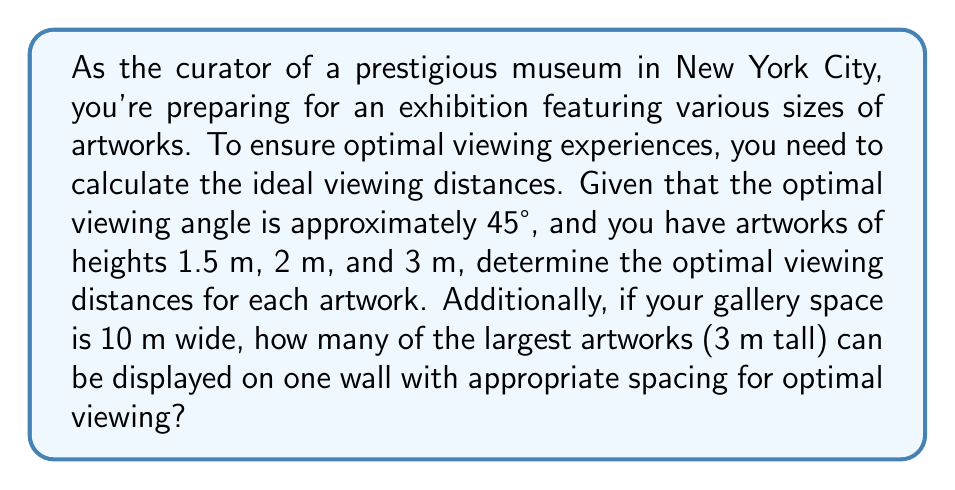Provide a solution to this math problem. To solve this problem, we'll use principles of functional analysis and geometry:

1. Optimal viewing distance calculation:
   The optimal viewing angle of 45° forms an isosceles right triangle with the artwork height and viewing distance.

   Let $h$ be the height of the artwork and $d$ be the optimal viewing distance.
   
   Using the tangent function: $\tan(45°) = \frac{h}{d} = 1$

   Therefore, $d = h$

2. Calculate optimal viewing distances:
   - For 1.5 m tall artwork: $d_1 = 1.5$ m
   - For 2 m tall artwork: $d_2 = 2$ m
   - For 3 m tall artwork: $d_3 = 3$ m

3. Number of large artworks on one wall:
   For the 3 m tall artworks, we need:
   - 3 m viewing distance in front of each artwork
   - 3 m width for each artwork (assuming square proportion)
   - Some space between artworks, let's say 1 m

   Total width needed for each artwork: $3 \text{ m} + 1 \text{ m} = 4 \text{ m}$

   Number of artworks that can fit: $\left\lfloor\frac{10 \text{ m}}{4 \text{ m}}\right\rfloor = 2$

   Where $\lfloor \cdot \rfloor$ denotes the floor function.

[asy]
unitsize(1cm);
draw((0,0)--(3,0)--(3,3)--(0,3)--cycle);
draw((3,0)--(6,3));
label("45°", (3.5,0.5), E);
label("3 m", (3.2,1.5), E);
label("3 m", (1.5,3.2), N);
label("Artwork", (1.5,1.5));
label("Viewer", (5.5,3.2), NE);
[/asy]
Answer: The optimal viewing distances are 1.5 m, 2 m, and 3 m for artworks of heights 1.5 m, 2 m, and 3 m, respectively. A maximum of 2 large artworks (3 m tall) can be displayed on one 10 m wide wall with appropriate spacing for optimal viewing. 